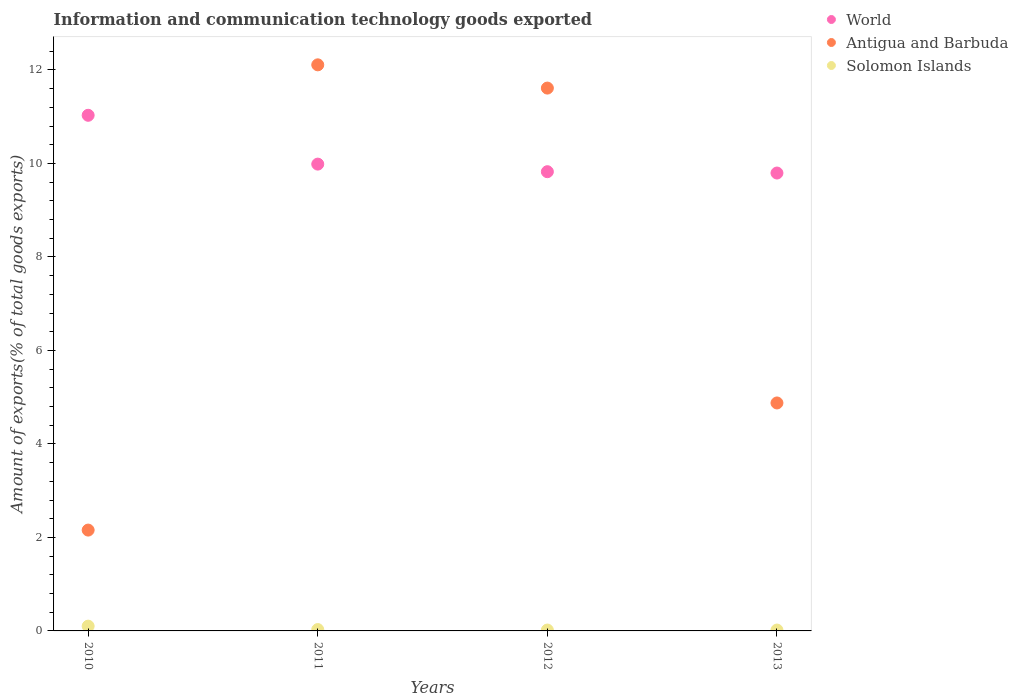How many different coloured dotlines are there?
Your answer should be very brief. 3. Is the number of dotlines equal to the number of legend labels?
Your response must be concise. Yes. What is the amount of goods exported in Antigua and Barbuda in 2012?
Make the answer very short. 11.61. Across all years, what is the maximum amount of goods exported in World?
Ensure brevity in your answer.  11.03. Across all years, what is the minimum amount of goods exported in Antigua and Barbuda?
Keep it short and to the point. 2.16. In which year was the amount of goods exported in Solomon Islands minimum?
Offer a very short reply. 2013. What is the total amount of goods exported in Solomon Islands in the graph?
Your response must be concise. 0.17. What is the difference between the amount of goods exported in Solomon Islands in 2011 and that in 2012?
Your response must be concise. 0.01. What is the difference between the amount of goods exported in Solomon Islands in 2010 and the amount of goods exported in Antigua and Barbuda in 2012?
Your answer should be very brief. -11.51. What is the average amount of goods exported in Antigua and Barbuda per year?
Offer a very short reply. 7.69. In the year 2013, what is the difference between the amount of goods exported in Solomon Islands and amount of goods exported in World?
Give a very brief answer. -9.78. What is the ratio of the amount of goods exported in Solomon Islands in 2012 to that in 2013?
Give a very brief answer. 1. Is the amount of goods exported in Antigua and Barbuda in 2011 less than that in 2012?
Your answer should be very brief. No. Is the difference between the amount of goods exported in Solomon Islands in 2012 and 2013 greater than the difference between the amount of goods exported in World in 2012 and 2013?
Ensure brevity in your answer.  No. What is the difference between the highest and the second highest amount of goods exported in Solomon Islands?
Provide a short and direct response. 0.07. What is the difference between the highest and the lowest amount of goods exported in World?
Your answer should be compact. 1.24. Is the sum of the amount of goods exported in World in 2010 and 2011 greater than the maximum amount of goods exported in Solomon Islands across all years?
Make the answer very short. Yes. Does the amount of goods exported in Antigua and Barbuda monotonically increase over the years?
Your response must be concise. No. How many years are there in the graph?
Give a very brief answer. 4. What is the difference between two consecutive major ticks on the Y-axis?
Offer a terse response. 2. Does the graph contain any zero values?
Your response must be concise. No. How many legend labels are there?
Your response must be concise. 3. What is the title of the graph?
Provide a succinct answer. Information and communication technology goods exported. What is the label or title of the Y-axis?
Keep it short and to the point. Amount of exports(% of total goods exports). What is the Amount of exports(% of total goods exports) of World in 2010?
Keep it short and to the point. 11.03. What is the Amount of exports(% of total goods exports) in Antigua and Barbuda in 2010?
Provide a succinct answer. 2.16. What is the Amount of exports(% of total goods exports) in Solomon Islands in 2010?
Your response must be concise. 0.1. What is the Amount of exports(% of total goods exports) in World in 2011?
Give a very brief answer. 9.98. What is the Amount of exports(% of total goods exports) of Antigua and Barbuda in 2011?
Your answer should be very brief. 12.11. What is the Amount of exports(% of total goods exports) of Solomon Islands in 2011?
Offer a terse response. 0.03. What is the Amount of exports(% of total goods exports) of World in 2012?
Offer a terse response. 9.82. What is the Amount of exports(% of total goods exports) in Antigua and Barbuda in 2012?
Offer a terse response. 11.61. What is the Amount of exports(% of total goods exports) in Solomon Islands in 2012?
Provide a short and direct response. 0.02. What is the Amount of exports(% of total goods exports) of World in 2013?
Offer a very short reply. 9.79. What is the Amount of exports(% of total goods exports) in Antigua and Barbuda in 2013?
Offer a terse response. 4.88. What is the Amount of exports(% of total goods exports) in Solomon Islands in 2013?
Offer a terse response. 0.02. Across all years, what is the maximum Amount of exports(% of total goods exports) in World?
Ensure brevity in your answer.  11.03. Across all years, what is the maximum Amount of exports(% of total goods exports) of Antigua and Barbuda?
Your answer should be very brief. 12.11. Across all years, what is the maximum Amount of exports(% of total goods exports) in Solomon Islands?
Offer a terse response. 0.1. Across all years, what is the minimum Amount of exports(% of total goods exports) in World?
Give a very brief answer. 9.79. Across all years, what is the minimum Amount of exports(% of total goods exports) of Antigua and Barbuda?
Give a very brief answer. 2.16. Across all years, what is the minimum Amount of exports(% of total goods exports) in Solomon Islands?
Provide a short and direct response. 0.02. What is the total Amount of exports(% of total goods exports) in World in the graph?
Make the answer very short. 40.63. What is the total Amount of exports(% of total goods exports) of Antigua and Barbuda in the graph?
Offer a very short reply. 30.75. What is the total Amount of exports(% of total goods exports) in Solomon Islands in the graph?
Your answer should be compact. 0.17. What is the difference between the Amount of exports(% of total goods exports) of World in 2010 and that in 2011?
Offer a terse response. 1.04. What is the difference between the Amount of exports(% of total goods exports) in Antigua and Barbuda in 2010 and that in 2011?
Give a very brief answer. -9.95. What is the difference between the Amount of exports(% of total goods exports) of Solomon Islands in 2010 and that in 2011?
Your answer should be compact. 0.07. What is the difference between the Amount of exports(% of total goods exports) in World in 2010 and that in 2012?
Your response must be concise. 1.21. What is the difference between the Amount of exports(% of total goods exports) in Antigua and Barbuda in 2010 and that in 2012?
Give a very brief answer. -9.45. What is the difference between the Amount of exports(% of total goods exports) in Solomon Islands in 2010 and that in 2012?
Make the answer very short. 0.08. What is the difference between the Amount of exports(% of total goods exports) of World in 2010 and that in 2013?
Offer a terse response. 1.24. What is the difference between the Amount of exports(% of total goods exports) in Antigua and Barbuda in 2010 and that in 2013?
Ensure brevity in your answer.  -2.72. What is the difference between the Amount of exports(% of total goods exports) of Solomon Islands in 2010 and that in 2013?
Provide a succinct answer. 0.08. What is the difference between the Amount of exports(% of total goods exports) of World in 2011 and that in 2012?
Your answer should be very brief. 0.16. What is the difference between the Amount of exports(% of total goods exports) of Antigua and Barbuda in 2011 and that in 2012?
Your answer should be very brief. 0.5. What is the difference between the Amount of exports(% of total goods exports) of Solomon Islands in 2011 and that in 2012?
Provide a succinct answer. 0.01. What is the difference between the Amount of exports(% of total goods exports) of World in 2011 and that in 2013?
Offer a terse response. 0.19. What is the difference between the Amount of exports(% of total goods exports) of Antigua and Barbuda in 2011 and that in 2013?
Your answer should be compact. 7.23. What is the difference between the Amount of exports(% of total goods exports) of Solomon Islands in 2011 and that in 2013?
Keep it short and to the point. 0.01. What is the difference between the Amount of exports(% of total goods exports) of World in 2012 and that in 2013?
Offer a very short reply. 0.03. What is the difference between the Amount of exports(% of total goods exports) in Antigua and Barbuda in 2012 and that in 2013?
Keep it short and to the point. 6.74. What is the difference between the Amount of exports(% of total goods exports) of World in 2010 and the Amount of exports(% of total goods exports) of Antigua and Barbuda in 2011?
Give a very brief answer. -1.08. What is the difference between the Amount of exports(% of total goods exports) in World in 2010 and the Amount of exports(% of total goods exports) in Solomon Islands in 2011?
Ensure brevity in your answer.  11. What is the difference between the Amount of exports(% of total goods exports) of Antigua and Barbuda in 2010 and the Amount of exports(% of total goods exports) of Solomon Islands in 2011?
Your response must be concise. 2.13. What is the difference between the Amount of exports(% of total goods exports) in World in 2010 and the Amount of exports(% of total goods exports) in Antigua and Barbuda in 2012?
Offer a terse response. -0.58. What is the difference between the Amount of exports(% of total goods exports) in World in 2010 and the Amount of exports(% of total goods exports) in Solomon Islands in 2012?
Give a very brief answer. 11.01. What is the difference between the Amount of exports(% of total goods exports) in Antigua and Barbuda in 2010 and the Amount of exports(% of total goods exports) in Solomon Islands in 2012?
Your answer should be very brief. 2.14. What is the difference between the Amount of exports(% of total goods exports) of World in 2010 and the Amount of exports(% of total goods exports) of Antigua and Barbuda in 2013?
Offer a very short reply. 6.15. What is the difference between the Amount of exports(% of total goods exports) in World in 2010 and the Amount of exports(% of total goods exports) in Solomon Islands in 2013?
Your answer should be very brief. 11.01. What is the difference between the Amount of exports(% of total goods exports) of Antigua and Barbuda in 2010 and the Amount of exports(% of total goods exports) of Solomon Islands in 2013?
Provide a short and direct response. 2.14. What is the difference between the Amount of exports(% of total goods exports) of World in 2011 and the Amount of exports(% of total goods exports) of Antigua and Barbuda in 2012?
Provide a succinct answer. -1.63. What is the difference between the Amount of exports(% of total goods exports) in World in 2011 and the Amount of exports(% of total goods exports) in Solomon Islands in 2012?
Keep it short and to the point. 9.97. What is the difference between the Amount of exports(% of total goods exports) in Antigua and Barbuda in 2011 and the Amount of exports(% of total goods exports) in Solomon Islands in 2012?
Offer a terse response. 12.09. What is the difference between the Amount of exports(% of total goods exports) of World in 2011 and the Amount of exports(% of total goods exports) of Antigua and Barbuda in 2013?
Provide a succinct answer. 5.11. What is the difference between the Amount of exports(% of total goods exports) in World in 2011 and the Amount of exports(% of total goods exports) in Solomon Islands in 2013?
Provide a succinct answer. 9.97. What is the difference between the Amount of exports(% of total goods exports) in Antigua and Barbuda in 2011 and the Amount of exports(% of total goods exports) in Solomon Islands in 2013?
Your response must be concise. 12.09. What is the difference between the Amount of exports(% of total goods exports) of World in 2012 and the Amount of exports(% of total goods exports) of Antigua and Barbuda in 2013?
Provide a succinct answer. 4.95. What is the difference between the Amount of exports(% of total goods exports) in World in 2012 and the Amount of exports(% of total goods exports) in Solomon Islands in 2013?
Your response must be concise. 9.8. What is the difference between the Amount of exports(% of total goods exports) of Antigua and Barbuda in 2012 and the Amount of exports(% of total goods exports) of Solomon Islands in 2013?
Provide a short and direct response. 11.59. What is the average Amount of exports(% of total goods exports) in World per year?
Give a very brief answer. 10.16. What is the average Amount of exports(% of total goods exports) in Antigua and Barbuda per year?
Give a very brief answer. 7.69. What is the average Amount of exports(% of total goods exports) of Solomon Islands per year?
Your answer should be very brief. 0.04. In the year 2010, what is the difference between the Amount of exports(% of total goods exports) in World and Amount of exports(% of total goods exports) in Antigua and Barbuda?
Offer a terse response. 8.87. In the year 2010, what is the difference between the Amount of exports(% of total goods exports) of World and Amount of exports(% of total goods exports) of Solomon Islands?
Offer a terse response. 10.93. In the year 2010, what is the difference between the Amount of exports(% of total goods exports) of Antigua and Barbuda and Amount of exports(% of total goods exports) of Solomon Islands?
Keep it short and to the point. 2.05. In the year 2011, what is the difference between the Amount of exports(% of total goods exports) of World and Amount of exports(% of total goods exports) of Antigua and Barbuda?
Offer a very short reply. -2.12. In the year 2011, what is the difference between the Amount of exports(% of total goods exports) of World and Amount of exports(% of total goods exports) of Solomon Islands?
Offer a very short reply. 9.96. In the year 2011, what is the difference between the Amount of exports(% of total goods exports) in Antigua and Barbuda and Amount of exports(% of total goods exports) in Solomon Islands?
Provide a succinct answer. 12.08. In the year 2012, what is the difference between the Amount of exports(% of total goods exports) in World and Amount of exports(% of total goods exports) in Antigua and Barbuda?
Your answer should be compact. -1.79. In the year 2012, what is the difference between the Amount of exports(% of total goods exports) in World and Amount of exports(% of total goods exports) in Solomon Islands?
Your response must be concise. 9.8. In the year 2012, what is the difference between the Amount of exports(% of total goods exports) in Antigua and Barbuda and Amount of exports(% of total goods exports) in Solomon Islands?
Keep it short and to the point. 11.59. In the year 2013, what is the difference between the Amount of exports(% of total goods exports) of World and Amount of exports(% of total goods exports) of Antigua and Barbuda?
Provide a short and direct response. 4.92. In the year 2013, what is the difference between the Amount of exports(% of total goods exports) of World and Amount of exports(% of total goods exports) of Solomon Islands?
Offer a terse response. 9.78. In the year 2013, what is the difference between the Amount of exports(% of total goods exports) in Antigua and Barbuda and Amount of exports(% of total goods exports) in Solomon Islands?
Provide a succinct answer. 4.86. What is the ratio of the Amount of exports(% of total goods exports) in World in 2010 to that in 2011?
Offer a terse response. 1.1. What is the ratio of the Amount of exports(% of total goods exports) in Antigua and Barbuda in 2010 to that in 2011?
Provide a short and direct response. 0.18. What is the ratio of the Amount of exports(% of total goods exports) in Solomon Islands in 2010 to that in 2011?
Your response must be concise. 3.5. What is the ratio of the Amount of exports(% of total goods exports) in World in 2010 to that in 2012?
Your response must be concise. 1.12. What is the ratio of the Amount of exports(% of total goods exports) in Antigua and Barbuda in 2010 to that in 2012?
Provide a short and direct response. 0.19. What is the ratio of the Amount of exports(% of total goods exports) of Solomon Islands in 2010 to that in 2012?
Provide a succinct answer. 5.45. What is the ratio of the Amount of exports(% of total goods exports) in World in 2010 to that in 2013?
Your response must be concise. 1.13. What is the ratio of the Amount of exports(% of total goods exports) of Antigua and Barbuda in 2010 to that in 2013?
Keep it short and to the point. 0.44. What is the ratio of the Amount of exports(% of total goods exports) of Solomon Islands in 2010 to that in 2013?
Offer a terse response. 5.45. What is the ratio of the Amount of exports(% of total goods exports) in World in 2011 to that in 2012?
Provide a succinct answer. 1.02. What is the ratio of the Amount of exports(% of total goods exports) of Antigua and Barbuda in 2011 to that in 2012?
Provide a short and direct response. 1.04. What is the ratio of the Amount of exports(% of total goods exports) of Solomon Islands in 2011 to that in 2012?
Your answer should be compact. 1.55. What is the ratio of the Amount of exports(% of total goods exports) in World in 2011 to that in 2013?
Your response must be concise. 1.02. What is the ratio of the Amount of exports(% of total goods exports) of Antigua and Barbuda in 2011 to that in 2013?
Provide a succinct answer. 2.48. What is the ratio of the Amount of exports(% of total goods exports) in Solomon Islands in 2011 to that in 2013?
Offer a very short reply. 1.56. What is the ratio of the Amount of exports(% of total goods exports) in Antigua and Barbuda in 2012 to that in 2013?
Your response must be concise. 2.38. What is the ratio of the Amount of exports(% of total goods exports) in Solomon Islands in 2012 to that in 2013?
Ensure brevity in your answer.  1. What is the difference between the highest and the second highest Amount of exports(% of total goods exports) in World?
Your answer should be very brief. 1.04. What is the difference between the highest and the second highest Amount of exports(% of total goods exports) in Antigua and Barbuda?
Your response must be concise. 0.5. What is the difference between the highest and the second highest Amount of exports(% of total goods exports) in Solomon Islands?
Your answer should be very brief. 0.07. What is the difference between the highest and the lowest Amount of exports(% of total goods exports) in World?
Give a very brief answer. 1.24. What is the difference between the highest and the lowest Amount of exports(% of total goods exports) in Antigua and Barbuda?
Give a very brief answer. 9.95. What is the difference between the highest and the lowest Amount of exports(% of total goods exports) in Solomon Islands?
Give a very brief answer. 0.08. 